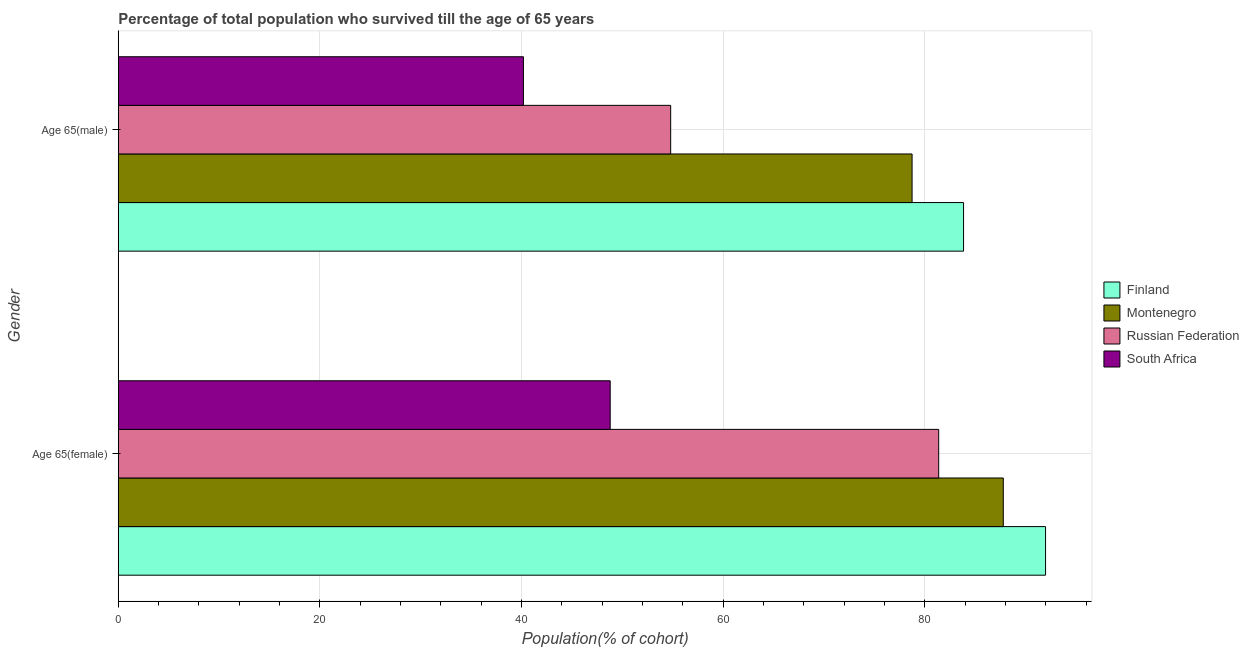How many groups of bars are there?
Keep it short and to the point. 2. Are the number of bars on each tick of the Y-axis equal?
Provide a short and direct response. Yes. How many bars are there on the 1st tick from the top?
Give a very brief answer. 4. What is the label of the 1st group of bars from the top?
Ensure brevity in your answer.  Age 65(male). What is the percentage of male population who survived till age of 65 in Montenegro?
Keep it short and to the point. 78.72. Across all countries, what is the maximum percentage of female population who survived till age of 65?
Give a very brief answer. 91.96. Across all countries, what is the minimum percentage of female population who survived till age of 65?
Provide a succinct answer. 48.78. In which country was the percentage of female population who survived till age of 65 minimum?
Your response must be concise. South Africa. What is the total percentage of female population who survived till age of 65 in the graph?
Your answer should be compact. 309.86. What is the difference between the percentage of male population who survived till age of 65 in Montenegro and that in South Africa?
Your answer should be very brief. 38.54. What is the difference between the percentage of female population who survived till age of 65 in Russian Federation and the percentage of male population who survived till age of 65 in South Africa?
Ensure brevity in your answer.  41.18. What is the average percentage of female population who survived till age of 65 per country?
Give a very brief answer. 77.47. What is the difference between the percentage of male population who survived till age of 65 and percentage of female population who survived till age of 65 in Finland?
Offer a very short reply. -8.13. What is the ratio of the percentage of female population who survived till age of 65 in South Africa to that in Finland?
Provide a short and direct response. 0.53. Is the percentage of male population who survived till age of 65 in Russian Federation less than that in Finland?
Offer a terse response. Yes. In how many countries, is the percentage of female population who survived till age of 65 greater than the average percentage of female population who survived till age of 65 taken over all countries?
Make the answer very short. 3. What does the 2nd bar from the top in Age 65(female) represents?
Make the answer very short. Russian Federation. What does the 3rd bar from the bottom in Age 65(male) represents?
Give a very brief answer. Russian Federation. How many bars are there?
Give a very brief answer. 8. Are all the bars in the graph horizontal?
Your response must be concise. Yes. How many countries are there in the graph?
Provide a short and direct response. 4. What is the difference between two consecutive major ticks on the X-axis?
Your answer should be compact. 20. Does the graph contain any zero values?
Provide a short and direct response. No. Where does the legend appear in the graph?
Your response must be concise. Center right. How many legend labels are there?
Offer a terse response. 4. How are the legend labels stacked?
Your response must be concise. Vertical. What is the title of the graph?
Your response must be concise. Percentage of total population who survived till the age of 65 years. What is the label or title of the X-axis?
Your response must be concise. Population(% of cohort). What is the label or title of the Y-axis?
Make the answer very short. Gender. What is the Population(% of cohort) of Finland in Age 65(female)?
Your answer should be compact. 91.96. What is the Population(% of cohort) in Montenegro in Age 65(female)?
Provide a succinct answer. 87.77. What is the Population(% of cohort) of Russian Federation in Age 65(female)?
Offer a terse response. 81.36. What is the Population(% of cohort) in South Africa in Age 65(female)?
Provide a short and direct response. 48.78. What is the Population(% of cohort) of Finland in Age 65(male)?
Provide a short and direct response. 83.82. What is the Population(% of cohort) of Montenegro in Age 65(male)?
Provide a succinct answer. 78.72. What is the Population(% of cohort) in Russian Federation in Age 65(male)?
Your answer should be compact. 54.78. What is the Population(% of cohort) in South Africa in Age 65(male)?
Make the answer very short. 40.18. Across all Gender, what is the maximum Population(% of cohort) in Finland?
Ensure brevity in your answer.  91.96. Across all Gender, what is the maximum Population(% of cohort) in Montenegro?
Offer a very short reply. 87.77. Across all Gender, what is the maximum Population(% of cohort) of Russian Federation?
Provide a succinct answer. 81.36. Across all Gender, what is the maximum Population(% of cohort) of South Africa?
Your answer should be very brief. 48.78. Across all Gender, what is the minimum Population(% of cohort) in Finland?
Offer a very short reply. 83.82. Across all Gender, what is the minimum Population(% of cohort) of Montenegro?
Ensure brevity in your answer.  78.72. Across all Gender, what is the minimum Population(% of cohort) of Russian Federation?
Provide a short and direct response. 54.78. Across all Gender, what is the minimum Population(% of cohort) of South Africa?
Offer a terse response. 40.18. What is the total Population(% of cohort) of Finland in the graph?
Provide a succinct answer. 175.78. What is the total Population(% of cohort) of Montenegro in the graph?
Ensure brevity in your answer.  166.49. What is the total Population(% of cohort) of Russian Federation in the graph?
Ensure brevity in your answer.  136.14. What is the total Population(% of cohort) in South Africa in the graph?
Give a very brief answer. 88.96. What is the difference between the Population(% of cohort) of Finland in Age 65(female) and that in Age 65(male)?
Ensure brevity in your answer.  8.13. What is the difference between the Population(% of cohort) in Montenegro in Age 65(female) and that in Age 65(male)?
Give a very brief answer. 9.05. What is the difference between the Population(% of cohort) in Russian Federation in Age 65(female) and that in Age 65(male)?
Give a very brief answer. 26.58. What is the difference between the Population(% of cohort) in South Africa in Age 65(female) and that in Age 65(male)?
Offer a very short reply. 8.6. What is the difference between the Population(% of cohort) of Finland in Age 65(female) and the Population(% of cohort) of Montenegro in Age 65(male)?
Make the answer very short. 13.24. What is the difference between the Population(% of cohort) in Finland in Age 65(female) and the Population(% of cohort) in Russian Federation in Age 65(male)?
Give a very brief answer. 37.18. What is the difference between the Population(% of cohort) of Finland in Age 65(female) and the Population(% of cohort) of South Africa in Age 65(male)?
Give a very brief answer. 51.78. What is the difference between the Population(% of cohort) of Montenegro in Age 65(female) and the Population(% of cohort) of Russian Federation in Age 65(male)?
Offer a terse response. 32.99. What is the difference between the Population(% of cohort) in Montenegro in Age 65(female) and the Population(% of cohort) in South Africa in Age 65(male)?
Ensure brevity in your answer.  47.59. What is the difference between the Population(% of cohort) of Russian Federation in Age 65(female) and the Population(% of cohort) of South Africa in Age 65(male)?
Your answer should be very brief. 41.18. What is the average Population(% of cohort) in Finland per Gender?
Your answer should be very brief. 87.89. What is the average Population(% of cohort) of Montenegro per Gender?
Offer a terse response. 83.24. What is the average Population(% of cohort) of Russian Federation per Gender?
Keep it short and to the point. 68.07. What is the average Population(% of cohort) of South Africa per Gender?
Your answer should be very brief. 44.48. What is the difference between the Population(% of cohort) of Finland and Population(% of cohort) of Montenegro in Age 65(female)?
Your answer should be compact. 4.19. What is the difference between the Population(% of cohort) of Finland and Population(% of cohort) of Russian Federation in Age 65(female)?
Provide a succinct answer. 10.6. What is the difference between the Population(% of cohort) of Finland and Population(% of cohort) of South Africa in Age 65(female)?
Ensure brevity in your answer.  43.18. What is the difference between the Population(% of cohort) of Montenegro and Population(% of cohort) of Russian Federation in Age 65(female)?
Keep it short and to the point. 6.41. What is the difference between the Population(% of cohort) in Montenegro and Population(% of cohort) in South Africa in Age 65(female)?
Provide a succinct answer. 38.99. What is the difference between the Population(% of cohort) of Russian Federation and Population(% of cohort) of South Africa in Age 65(female)?
Ensure brevity in your answer.  32.58. What is the difference between the Population(% of cohort) of Finland and Population(% of cohort) of Montenegro in Age 65(male)?
Ensure brevity in your answer.  5.1. What is the difference between the Population(% of cohort) of Finland and Population(% of cohort) of Russian Federation in Age 65(male)?
Provide a succinct answer. 29.04. What is the difference between the Population(% of cohort) of Finland and Population(% of cohort) of South Africa in Age 65(male)?
Make the answer very short. 43.65. What is the difference between the Population(% of cohort) in Montenegro and Population(% of cohort) in Russian Federation in Age 65(male)?
Offer a terse response. 23.94. What is the difference between the Population(% of cohort) in Montenegro and Population(% of cohort) in South Africa in Age 65(male)?
Give a very brief answer. 38.54. What is the difference between the Population(% of cohort) in Russian Federation and Population(% of cohort) in South Africa in Age 65(male)?
Keep it short and to the point. 14.6. What is the ratio of the Population(% of cohort) in Finland in Age 65(female) to that in Age 65(male)?
Keep it short and to the point. 1.1. What is the ratio of the Population(% of cohort) in Montenegro in Age 65(female) to that in Age 65(male)?
Provide a short and direct response. 1.11. What is the ratio of the Population(% of cohort) of Russian Federation in Age 65(female) to that in Age 65(male)?
Your answer should be very brief. 1.49. What is the ratio of the Population(% of cohort) in South Africa in Age 65(female) to that in Age 65(male)?
Make the answer very short. 1.21. What is the difference between the highest and the second highest Population(% of cohort) of Finland?
Provide a short and direct response. 8.13. What is the difference between the highest and the second highest Population(% of cohort) in Montenegro?
Your answer should be very brief. 9.05. What is the difference between the highest and the second highest Population(% of cohort) of Russian Federation?
Your response must be concise. 26.58. What is the difference between the highest and the second highest Population(% of cohort) of South Africa?
Your response must be concise. 8.6. What is the difference between the highest and the lowest Population(% of cohort) of Finland?
Offer a very short reply. 8.13. What is the difference between the highest and the lowest Population(% of cohort) in Montenegro?
Offer a terse response. 9.05. What is the difference between the highest and the lowest Population(% of cohort) in Russian Federation?
Give a very brief answer. 26.58. What is the difference between the highest and the lowest Population(% of cohort) in South Africa?
Offer a terse response. 8.6. 